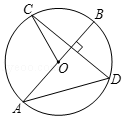What mathematical theorem or rule is illustrated by the chord CD and diameter AB intersecting at right angles? This particular configuration illustrates the theorem stating that if a diameter of a circle is perpendicular to a chord, then it bisects the chord and its arc, effectively creating two congruent segments and two congruent arcs. This setup can be used to explore properties of perpendicular bisectors in circles. 